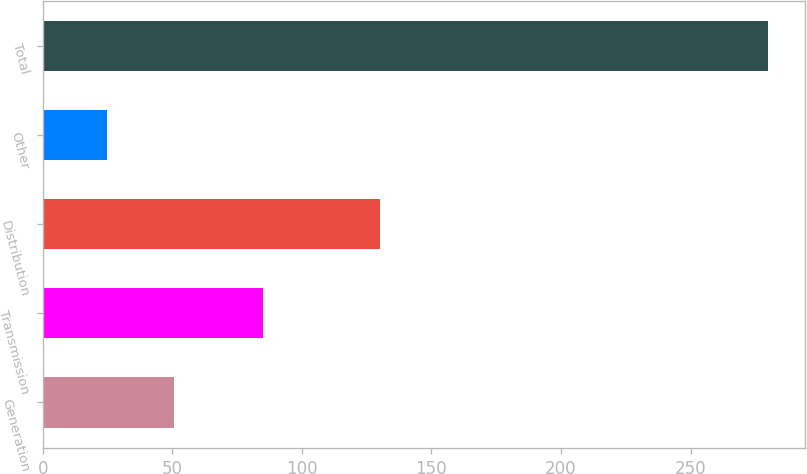<chart> <loc_0><loc_0><loc_500><loc_500><bar_chart><fcel>Generation<fcel>Transmission<fcel>Distribution<fcel>Other<fcel>Total<nl><fcel>50.5<fcel>85<fcel>130<fcel>25<fcel>280<nl></chart> 